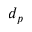<formula> <loc_0><loc_0><loc_500><loc_500>d _ { p }</formula> 